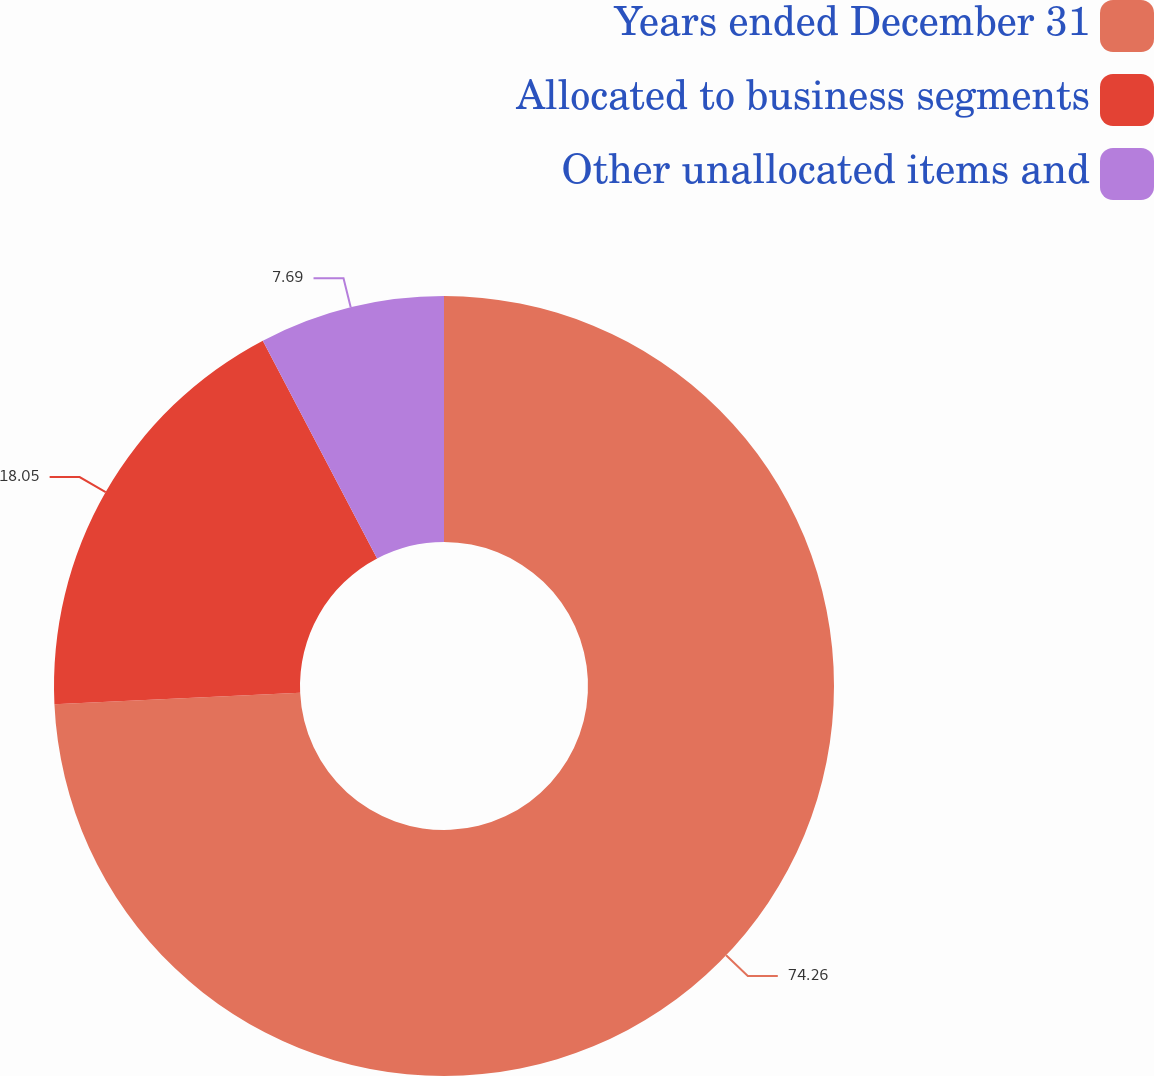<chart> <loc_0><loc_0><loc_500><loc_500><pie_chart><fcel>Years ended December 31<fcel>Allocated to business segments<fcel>Other unallocated items and<nl><fcel>74.26%<fcel>18.05%<fcel>7.69%<nl></chart> 